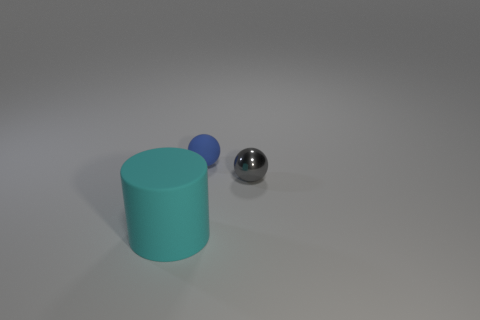Add 3 large red rubber blocks. How many objects exist? 6 Subtract all spheres. How many objects are left? 1 Subtract all small rubber balls. Subtract all small gray metallic objects. How many objects are left? 1 Add 2 large cyan rubber objects. How many large cyan rubber objects are left? 3 Add 1 small metal balls. How many small metal balls exist? 2 Subtract 0 red spheres. How many objects are left? 3 